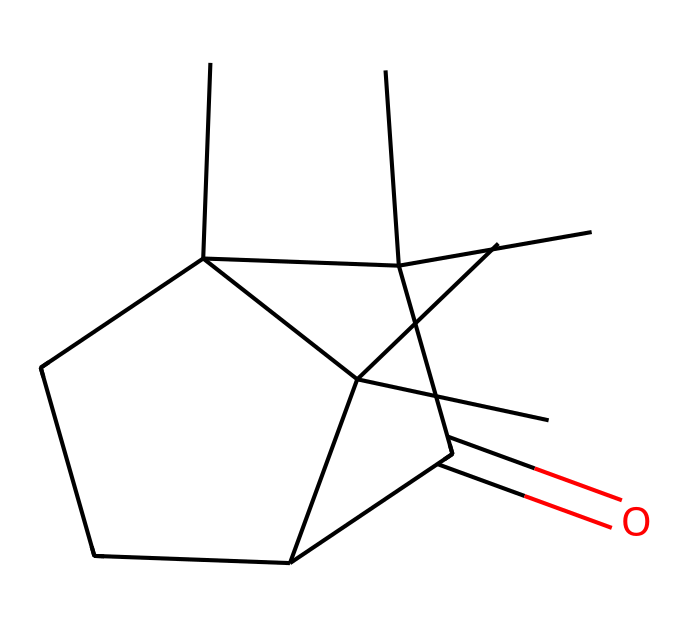how many carbon atoms are in camphor? In the SMILES representation, each "C" corresponds to a carbon atom. Counting all the "C" entries gives a total of 10 carbon atoms.
Answer: 10 what is the functional group present in camphor? The "C(=O)" part of the SMILES indicates a carbonyl group, which is a functional group in camphor.
Answer: carbonyl how many rings are present in the structure of camphor? The structure showcases cycloalkane properties, specifically two fused cyclopentane rings, which can be counted visually as two separate cyclic structures.
Answer: 2 what type of compound is camphor classified as? Based on its structure, camphor is classified as a bicyclic monoterpene, which is a type of cycloalkane compound.
Answer: bicyclic monoterpene what type of bonding is predominant in camphor? The structure of camphor has many single C-C bonds, with some double bonds indicated, so the predominant bonding type is sigma bonds.
Answer: sigma bonds 